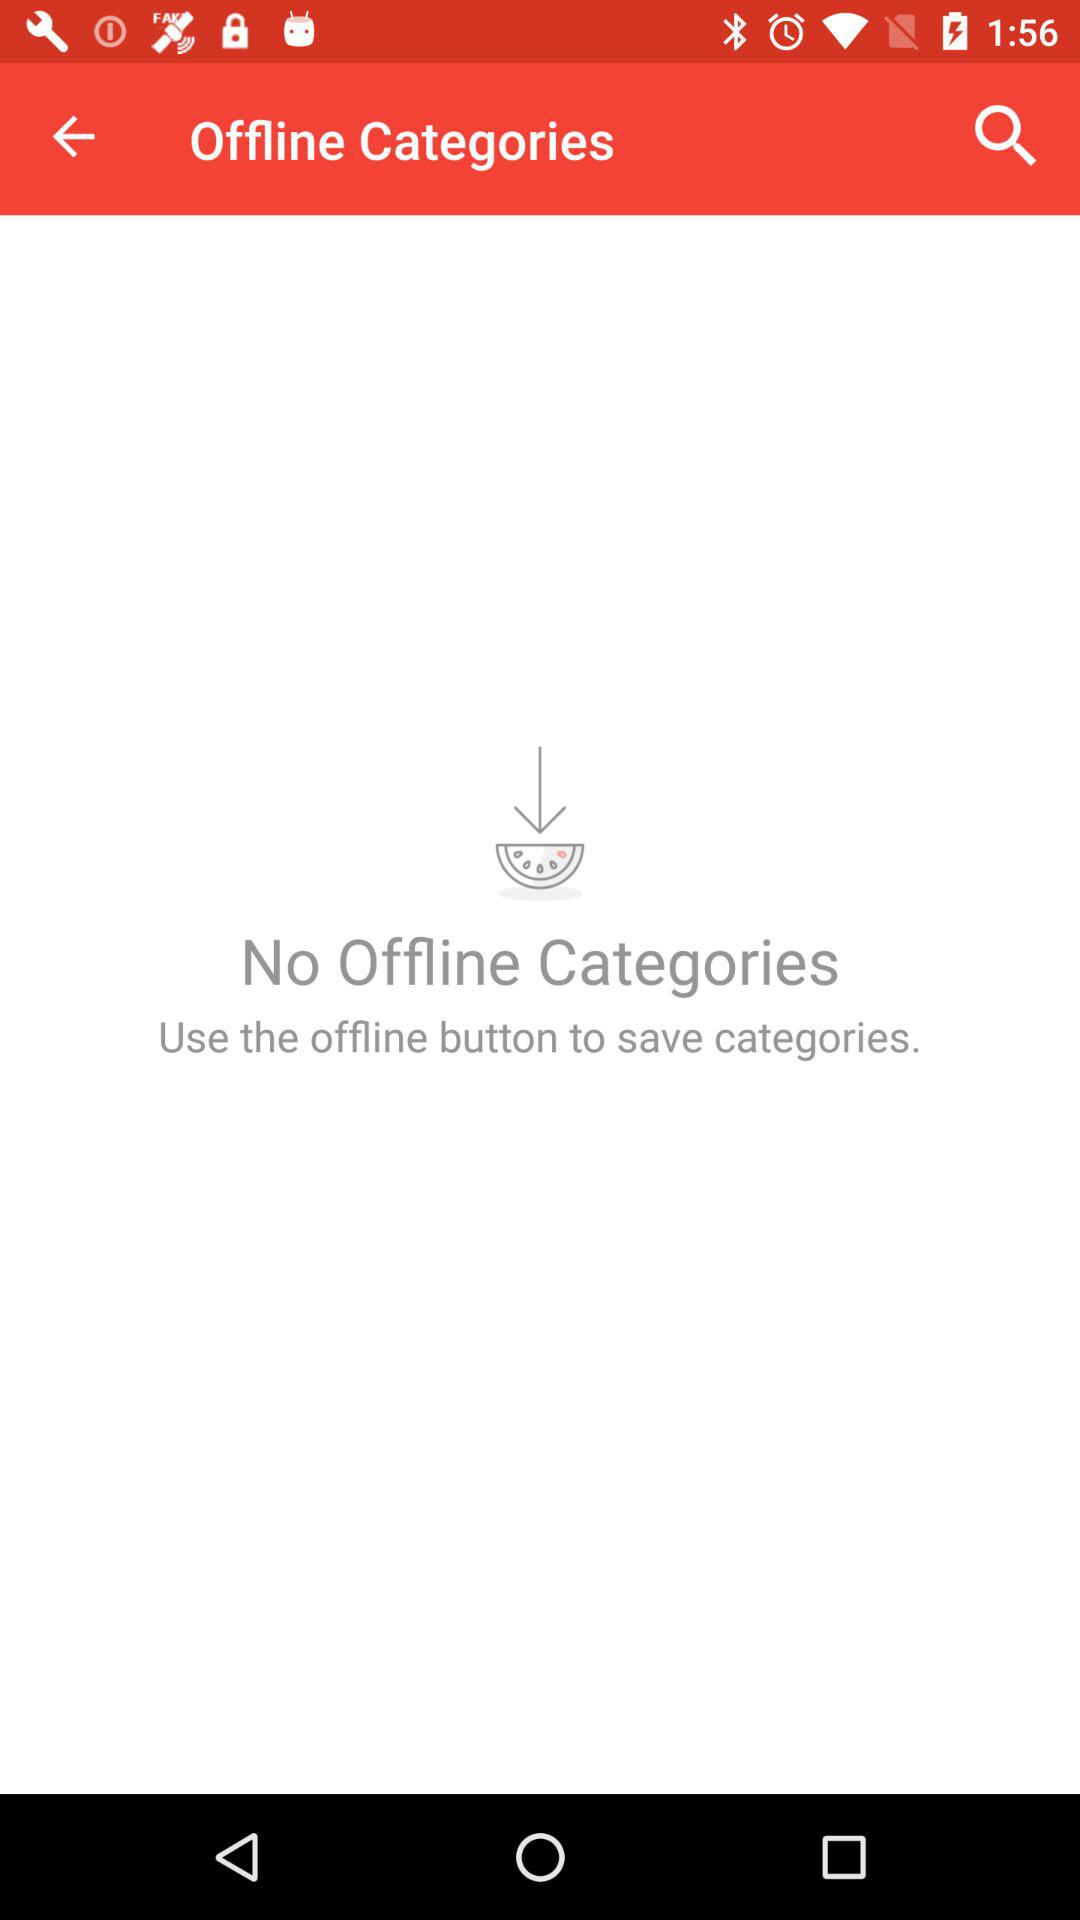What is the given button used to save the category? The given button is "offline button". 